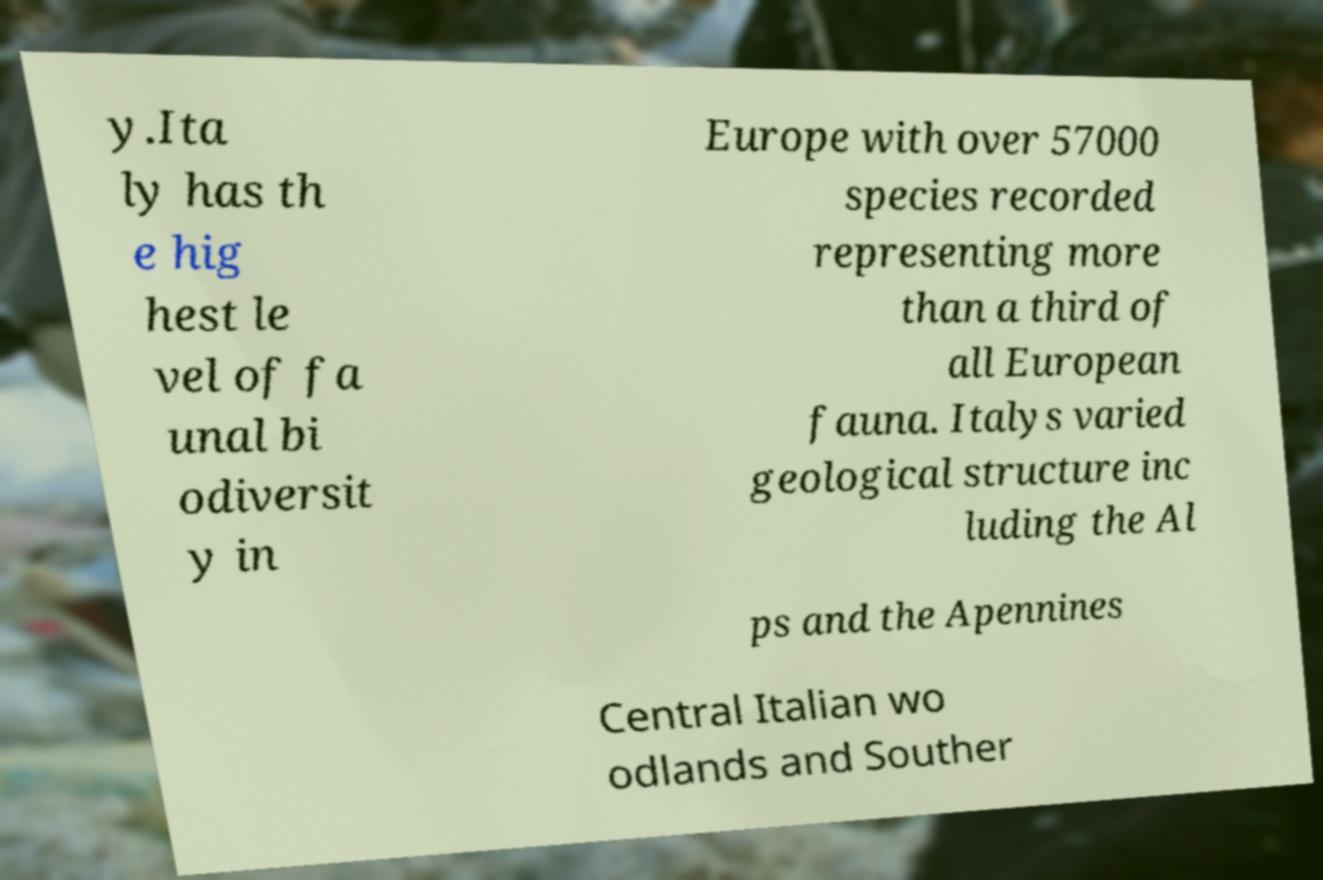Could you assist in decoding the text presented in this image and type it out clearly? y.Ita ly has th e hig hest le vel of fa unal bi odiversit y in Europe with over 57000 species recorded representing more than a third of all European fauna. Italys varied geological structure inc luding the Al ps and the Apennines Central Italian wo odlands and Souther 